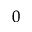<formula> <loc_0><loc_0><loc_500><loc_500>_ { 0 }</formula> 